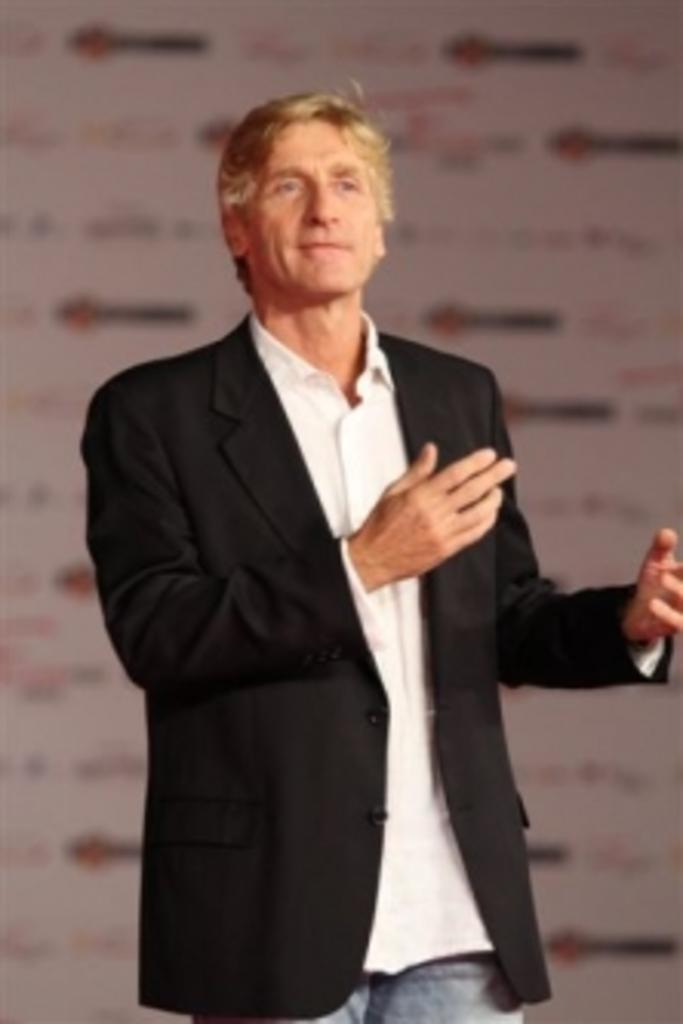Who or what is the main subject in the image? There is a person in the image. What is the person wearing? The person is wearing a black suit. What is the person's posture in the image? The person is standing. What can be seen behind the person? There is a banner behind the person. What type of cow can be seen in the image? There is no cow present in the image; it features a person wearing a black suit and standing in front of a banner. 